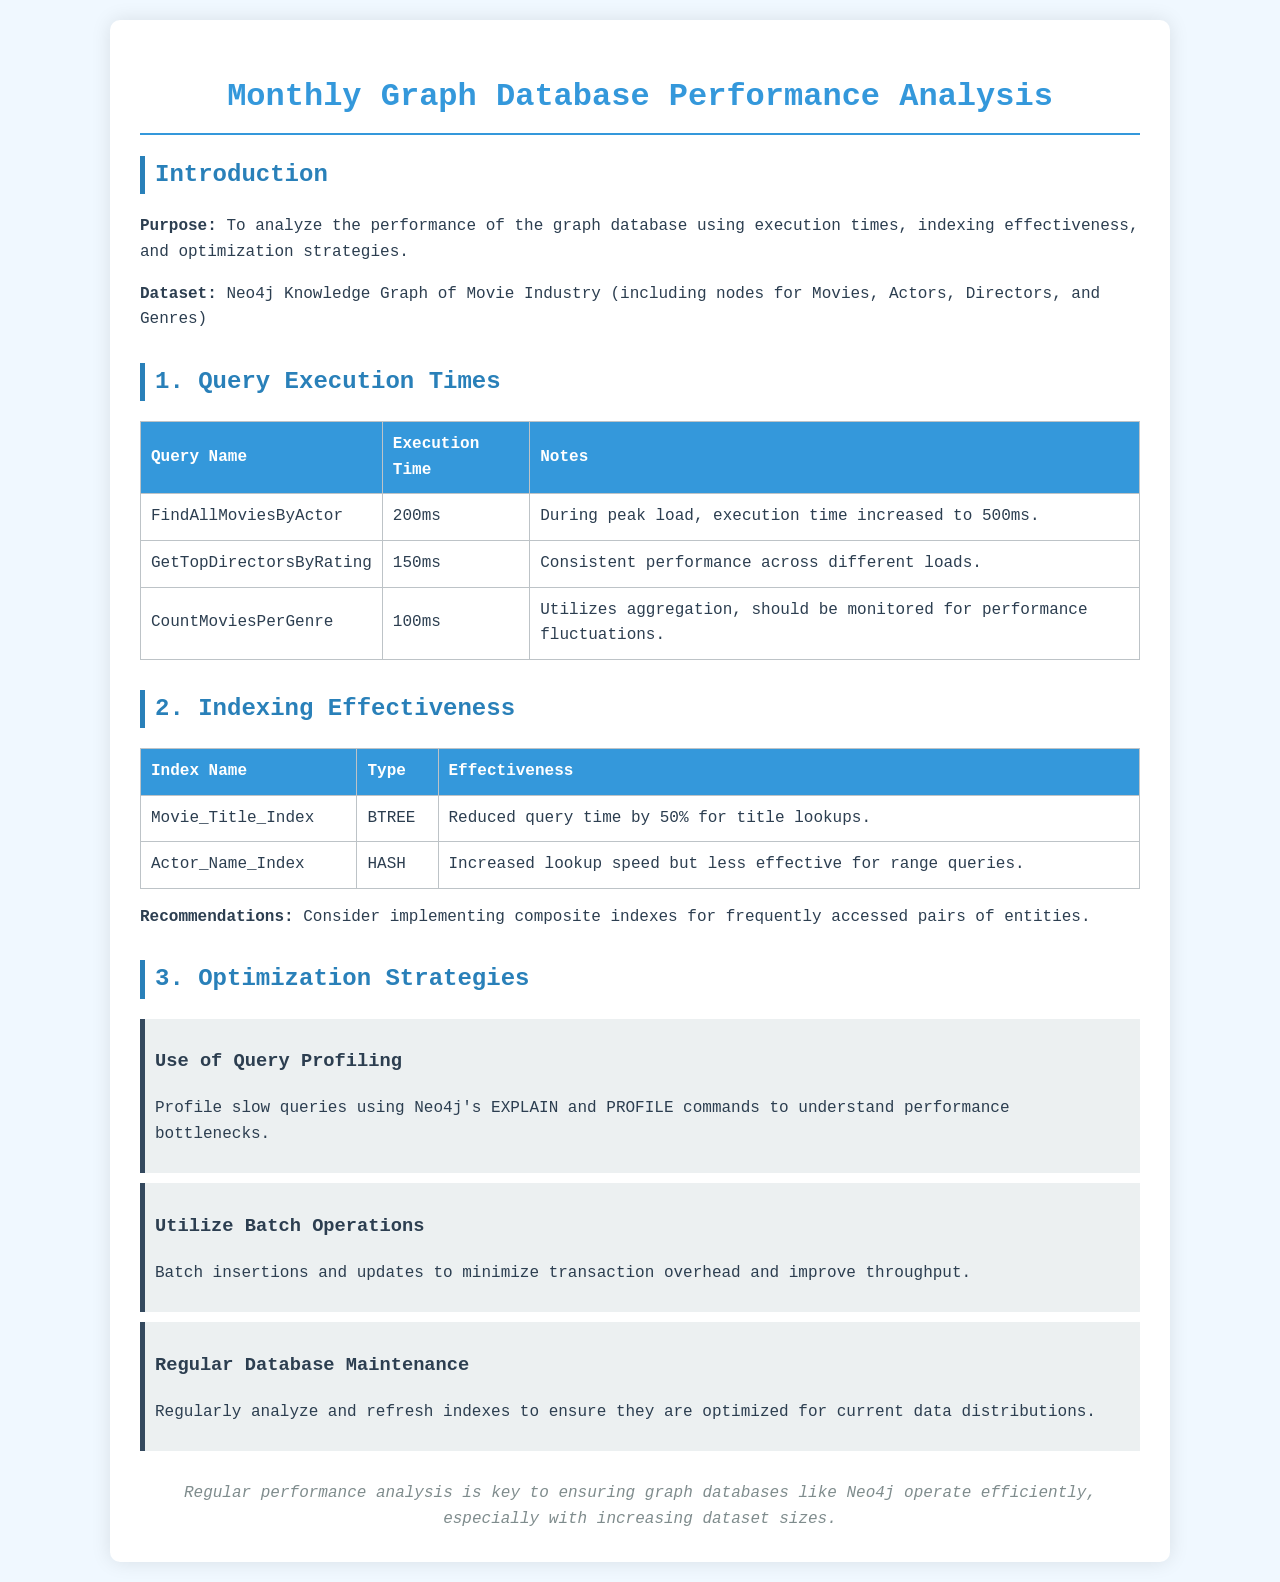What is the execution time for FindAllMoviesByActor? The execution time for FindAllMoviesByActor is listed in the document table under Query Execution Times.
Answer: 200ms What is the effectiveness of the Movie_Title_Index? The effectiveness of the Movie_Title_Index can be found in the Indexing Effectiveness section of the document.
Answer: Reduced query time by 50% for title lookups Which query has consistent performance across different loads? This information can be found in the Query Execution Times section that discusses multiple queries and their performance.
Answer: GetTopDirectorsByRating What optimization strategy suggests using Neo4j's EXPLAIN and PROFILE commands? The strategy section outlines various strategies for optimization, where this specific recommendation is mentioned.
Answer: Use of Query Profiling How much did the Actor_Name_Index increase lookup speed? The specifics on the speed increase for the Actor_Name_Index are noted in the Indexing Effectiveness table within the document.
Answer: Increased lookup speed but less effective for range queries What is the main purpose of the analysis? The purpose of the analysis is stated clearly in the Introduction section of the document.
Answer: To analyze the performance of the graph database using execution times, indexing effectiveness, and optimization strategies Which query saw an execution time increase during peak load? This detail is noted in the Query Execution Times section where execution times are discussed for various queries.
Answer: FindAllMoviesByActor What is recommended for frequently accessed pairs of entities? Recommendations are outlined under the Indexing Effectiveness section of the document.
Answer: Consider implementing composite indexes 